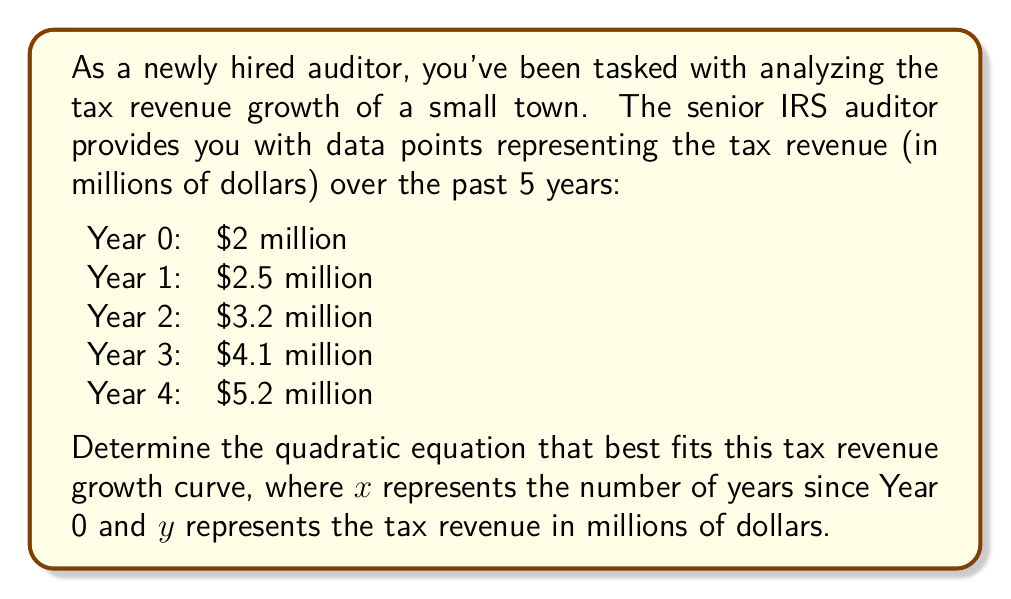Solve this math problem. To find the quadratic equation of the form $y = ax^2 + bx + c$ that best fits the given data points, we'll use the method of least squares:

1. Set up a system of equations using the given data points:
   $$\begin{cases}
   2 = a(0)^2 + b(0) + c \\
   2.5 = a(1)^2 + b(1) + c \\
   3.2 = a(2)^2 + b(2) + c \\
   4.1 = a(3)^2 + b(3) + c \\
   5.2 = a(4)^2 + b(4) + c
   \end{cases}$$

2. Simplify the equations:
   $$\begin{cases}
   2 = c \\
   2.5 = a + b + c \\
   3.2 = 4a + 2b + c \\
   4.1 = 9a + 3b + c \\
   5.2 = 16a + 4b + c
   \end{cases}$$

3. Subtract the first equation from the others to eliminate $c$:
   $$\begin{cases}
   0.5 = a + b \\
   1.2 = 4a + 2b \\
   2.1 = 9a + 3b \\
   3.2 = 16a + 4b
   \end{cases}$$

4. Use the first equation to substitute $b = 0.5 - a$ in the others:
   $$\begin{cases}
   1.2 = 4a + 2(0.5 - a) = 2a + 1 \\
   2.1 = 9a + 3(0.5 - a) = 6a + 1.5 \\
   3.2 = 16a + 4(0.5 - a) = 12a + 2
   \end{cases}$$

5. Simplify:
   $$\begin{cases}
   0.2 = 2a \\
   0.6 = 6a \\
   1.2 = 12a
   \end{cases}$$

6. Solve for $a$:
   $a = 0.1$

7. Substitute $a = 0.1$ into $b = 0.5 - a$:
   $b = 0.5 - 0.1 = 0.4$

8. Recall that $c = 2$ from the first equation in step 2.

Therefore, the quadratic equation that best fits the tax revenue growth curve is:
$$y = 0.1x^2 + 0.4x + 2$$
Answer: $y = 0.1x^2 + 0.4x + 2$ 